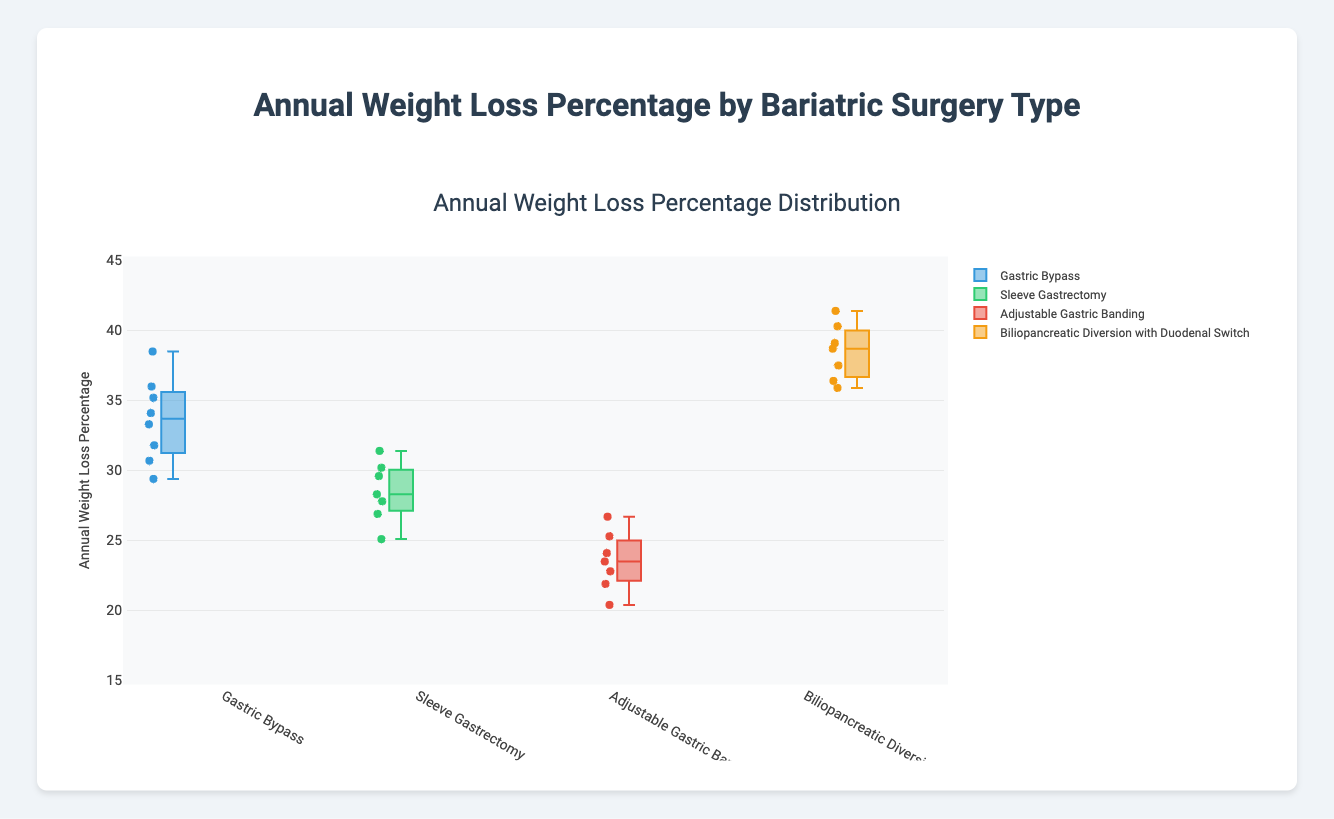Which surgery type has the highest median annual weight loss percentage? The median can be determined by the central line in each box plot. For "Biliopancreatic Diversion with Duodenal Switch", the median line is at its highest position compared to the other surgical types.
Answer: Biliopancreatic Diversion with Duodenal Switch What is the range of annual weight loss percentages for the "Sleeve Gastrectomy" group? In a box plot, the range is the difference between the highest and lowest points (whiskers). For "Sleeve Gastrectomy", the highest value is 31.4, and the lowest value is 25.1. The range is 31.4 - 25.1 = 6.3.
Answer: 6.3 Which surgical procedure has the smallest interquartile range (IQR)? The IQR is the difference between the first quartile (bottom of the box) and the third quartile (top of the box). Visually comparing all boxes, "Sleeve Gastrectomy" has the smallest vertical span, indicating the smallest IQR.
Answer: Sleeve Gastrectomy How do the outliers for "Adjustable Gastric Banding" compare with the medians of other groups? For "Adjustable Gastric Banding", the outliers are the points that lie outside the whiskers. The highest outlier here is at 26.7, which is considerably lower than the medians of "Gastric Bypass" and "Biliopancreatic Diversion with Duodenal Switch" but similar to the median of "Sleeve Gastrectomy".
Answer: Lower than Gastric Bypass and Biliopancreatic Diversion, similar to Sleeve Gastrectomy Among the surgical types, which has the largest spread in annual weight loss percentages? The spread can be inferred from the length of the whiskers. "Biliopancreatic Diversion with Duodenal Switch" has the largest distance between its lowest and highest points, indicating the largest spread.
Answer: Biliopancreatic Diversion with Duodenal Switch Compare the medians of "Gastric Bypass" and "Sleeve Gastrectomy". Which one is higher? The median is the horizontal line inside the box. The median for "Gastric Bypass" is higher compared to "Sleeve Gastrectomy".
Answer: Gastric Bypass Which surgery type shows the least variation in annual weight loss percentages? The least variation is indicated by the smallest distance between the first and third quartiles (IQR). "Sleeve Gastrectomy" has the shortest box height, indicating the least variation.
Answer: Sleeve Gastrectomy 